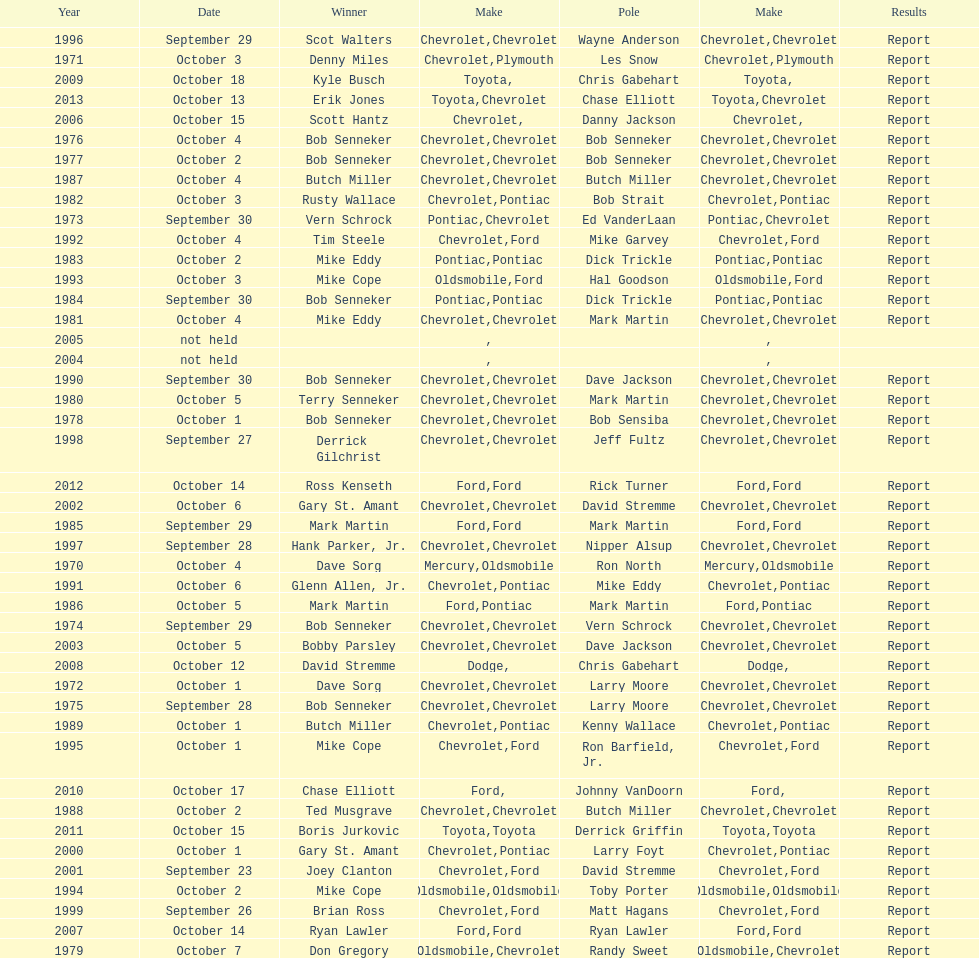Who among the list possesses the most consecutive triumphs? Bob Senneker. Parse the table in full. {'header': ['Year', 'Date', 'Winner', 'Make', 'Pole', 'Make', 'Results'], 'rows': [['1996', 'September 29', 'Scot Walters', 'Chevrolet', 'Wayne Anderson', 'Chevrolet', 'Report'], ['1971', 'October 3', 'Denny Miles', 'Chevrolet', 'Les Snow', 'Plymouth', 'Report'], ['2009', 'October 18', 'Kyle Busch', 'Toyota', 'Chris Gabehart', '', 'Report'], ['2013', 'October 13', 'Erik Jones', 'Toyota', 'Chase Elliott', 'Chevrolet', 'Report'], ['2006', 'October 15', 'Scott Hantz', 'Chevrolet', 'Danny Jackson', '', 'Report'], ['1976', 'October 4', 'Bob Senneker', 'Chevrolet', 'Bob Senneker', 'Chevrolet', 'Report'], ['1977', 'October 2', 'Bob Senneker', 'Chevrolet', 'Bob Senneker', 'Chevrolet', 'Report'], ['1987', 'October 4', 'Butch Miller', 'Chevrolet', 'Butch Miller', 'Chevrolet', 'Report'], ['1982', 'October 3', 'Rusty Wallace', 'Chevrolet', 'Bob Strait', 'Pontiac', 'Report'], ['1973', 'September 30', 'Vern Schrock', 'Pontiac', 'Ed VanderLaan', 'Chevrolet', 'Report'], ['1992', 'October 4', 'Tim Steele', 'Chevrolet', 'Mike Garvey', 'Ford', 'Report'], ['1983', 'October 2', 'Mike Eddy', 'Pontiac', 'Dick Trickle', 'Pontiac', 'Report'], ['1993', 'October 3', 'Mike Cope', 'Oldsmobile', 'Hal Goodson', 'Ford', 'Report'], ['1984', 'September 30', 'Bob Senneker', 'Pontiac', 'Dick Trickle', 'Pontiac', 'Report'], ['1981', 'October 4', 'Mike Eddy', 'Chevrolet', 'Mark Martin', 'Chevrolet', 'Report'], ['2005', 'not held', '', '', '', '', ''], ['2004', 'not held', '', '', '', '', ''], ['1990', 'September 30', 'Bob Senneker', 'Chevrolet', 'Dave Jackson', 'Chevrolet', 'Report'], ['1980', 'October 5', 'Terry Senneker', 'Chevrolet', 'Mark Martin', 'Chevrolet', 'Report'], ['1978', 'October 1', 'Bob Senneker', 'Chevrolet', 'Bob Sensiba', 'Chevrolet', 'Report'], ['1998', 'September 27', 'Derrick Gilchrist', 'Chevrolet', 'Jeff Fultz', 'Chevrolet', 'Report'], ['2012', 'October 14', 'Ross Kenseth', 'Ford', 'Rick Turner', 'Ford', 'Report'], ['2002', 'October 6', 'Gary St. Amant', 'Chevrolet', 'David Stremme', 'Chevrolet', 'Report'], ['1985', 'September 29', 'Mark Martin', 'Ford', 'Mark Martin', 'Ford', 'Report'], ['1997', 'September 28', 'Hank Parker, Jr.', 'Chevrolet', 'Nipper Alsup', 'Chevrolet', 'Report'], ['1970', 'October 4', 'Dave Sorg', 'Mercury', 'Ron North', 'Oldsmobile', 'Report'], ['1991', 'October 6', 'Glenn Allen, Jr.', 'Chevrolet', 'Mike Eddy', 'Pontiac', 'Report'], ['1986', 'October 5', 'Mark Martin', 'Ford', 'Mark Martin', 'Pontiac', 'Report'], ['1974', 'September 29', 'Bob Senneker', 'Chevrolet', 'Vern Schrock', 'Chevrolet', 'Report'], ['2003', 'October 5', 'Bobby Parsley', 'Chevrolet', 'Dave Jackson', 'Chevrolet', 'Report'], ['2008', 'October 12', 'David Stremme', 'Dodge', 'Chris Gabehart', '', 'Report'], ['1972', 'October 1', 'Dave Sorg', 'Chevrolet', 'Larry Moore', 'Chevrolet', 'Report'], ['1975', 'September 28', 'Bob Senneker', 'Chevrolet', 'Larry Moore', 'Chevrolet', 'Report'], ['1989', 'October 1', 'Butch Miller', 'Chevrolet', 'Kenny Wallace', 'Pontiac', 'Report'], ['1995', 'October 1', 'Mike Cope', 'Chevrolet', 'Ron Barfield, Jr.', 'Ford', 'Report'], ['2010', 'October 17', 'Chase Elliott', 'Ford', 'Johnny VanDoorn', '', 'Report'], ['1988', 'October 2', 'Ted Musgrave', 'Chevrolet', 'Butch Miller', 'Chevrolet', 'Report'], ['2011', 'October 15', 'Boris Jurkovic', 'Toyota', 'Derrick Griffin', 'Toyota', 'Report'], ['2000', 'October 1', 'Gary St. Amant', 'Chevrolet', 'Larry Foyt', 'Pontiac', 'Report'], ['2001', 'September 23', 'Joey Clanton', 'Chevrolet', 'David Stremme', 'Ford', 'Report'], ['1994', 'October 2', 'Mike Cope', 'Oldsmobile', 'Toby Porter', 'Oldsmobile', 'Report'], ['1999', 'September 26', 'Brian Ross', 'Chevrolet', 'Matt Hagans', 'Ford', 'Report'], ['2007', 'October 14', 'Ryan Lawler', 'Ford', 'Ryan Lawler', 'Ford', 'Report'], ['1979', 'October 7', 'Don Gregory', 'Oldsmobile', 'Randy Sweet', 'Chevrolet', 'Report']]} 